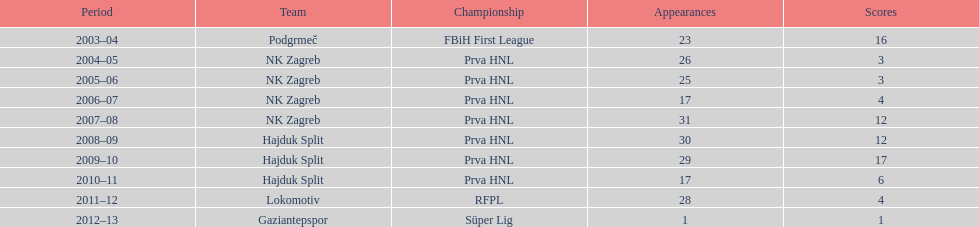What is the highest number of goals scored by senijad ibri&#269;i&#263; in a season? 35. 